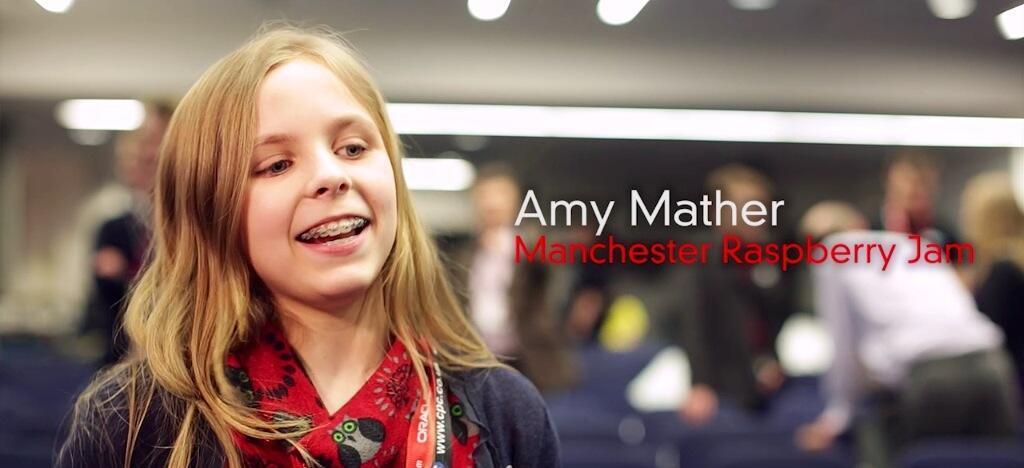How would you summarize this image in a sentence or two? In the center of the image we can see some text and we can see one woman is smiling. In the background, we can see it is blurred. 